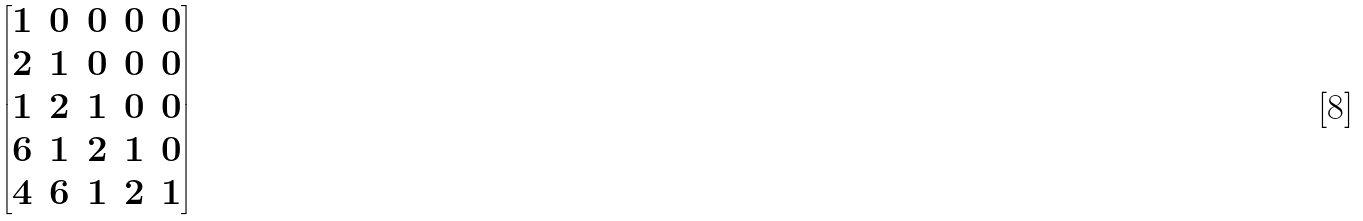<formula> <loc_0><loc_0><loc_500><loc_500>\begin{bmatrix} 1 & 0 & 0 & 0 & 0 \\ 2 & 1 & 0 & 0 & 0 \\ 1 & 2 & 1 & 0 & 0 \\ 6 & 1 & 2 & 1 & 0 \\ 4 & 6 & 1 & 2 & 1 \end{bmatrix}</formula> 